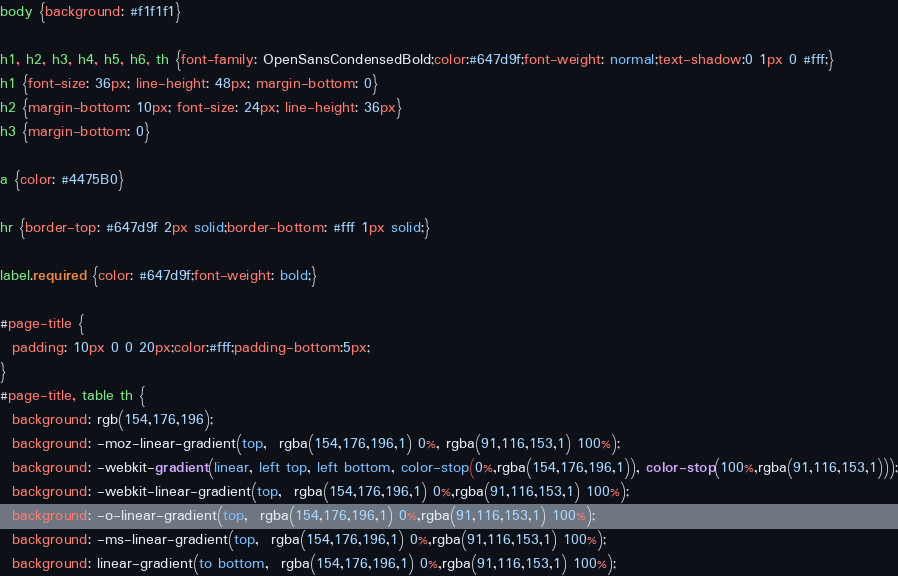<code> <loc_0><loc_0><loc_500><loc_500><_CSS_>body {background: #f1f1f1}

h1, h2, h3, h4, h5, h6, th {font-family: OpenSansCondensedBold;color:#647d9f;font-weight: normal;text-shadow:0 1px 0 #fff;}
h1 {font-size: 36px; line-height: 48px; margin-bottom: 0}
h2 {margin-bottom: 10px; font-size: 24px; line-height: 36px}
h3 {margin-bottom: 0}

a {color: #4475B0}

hr {border-top: #647d9f 2px solid;border-bottom: #fff 1px solid;}

label.required {color: #647d9f;font-weight: bold;}

#page-title {
  padding: 10px 0 0 20px;color:#fff;padding-bottom:5px;
}
#page-title, table th {
  background: rgb(154,176,196);
  background: -moz-linear-gradient(top,  rgba(154,176,196,1) 0%, rgba(91,116,153,1) 100%);
  background: -webkit-gradient(linear, left top, left bottom, color-stop(0%,rgba(154,176,196,1)), color-stop(100%,rgba(91,116,153,1)));
  background: -webkit-linear-gradient(top,  rgba(154,176,196,1) 0%,rgba(91,116,153,1) 100%);
  background: -o-linear-gradient(top,  rgba(154,176,196,1) 0%,rgba(91,116,153,1) 100%);
  background: -ms-linear-gradient(top,  rgba(154,176,196,1) 0%,rgba(91,116,153,1) 100%);
  background: linear-gradient(to bottom,  rgba(154,176,196,1) 0%,rgba(91,116,153,1) 100%);</code> 